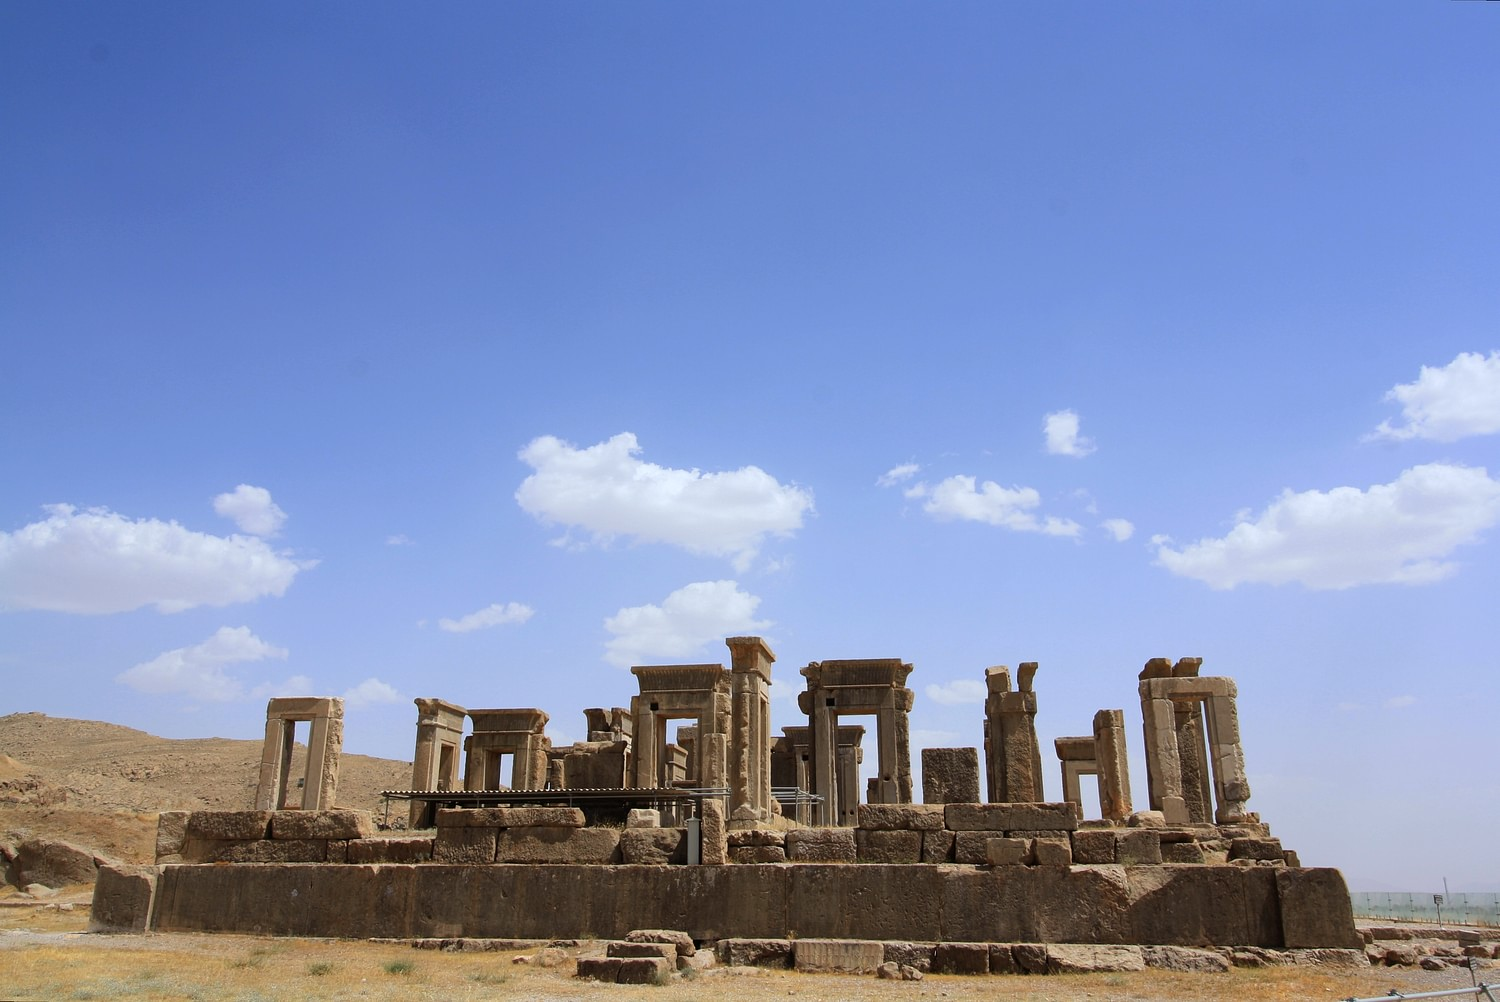What was Persepolis used for during the Achaemenid Empire? Persepolis served multiple functions during the Achaemenid Empire, primarily acting as a ceremonial complex and a place for the kings to host spectacular receptions and festivals. It was also a symbolic space, representing the empire's unity and the king’s authority. Important rituals such as the New Year's festival, Nowruz, were celebrated here, with representatives from all the provinces bringing gifts to the king, symbolizing their allegiance. This site was not only a political and religious center but also a place for demonstrating the cultural diversity and administrative complexity of the empire. 